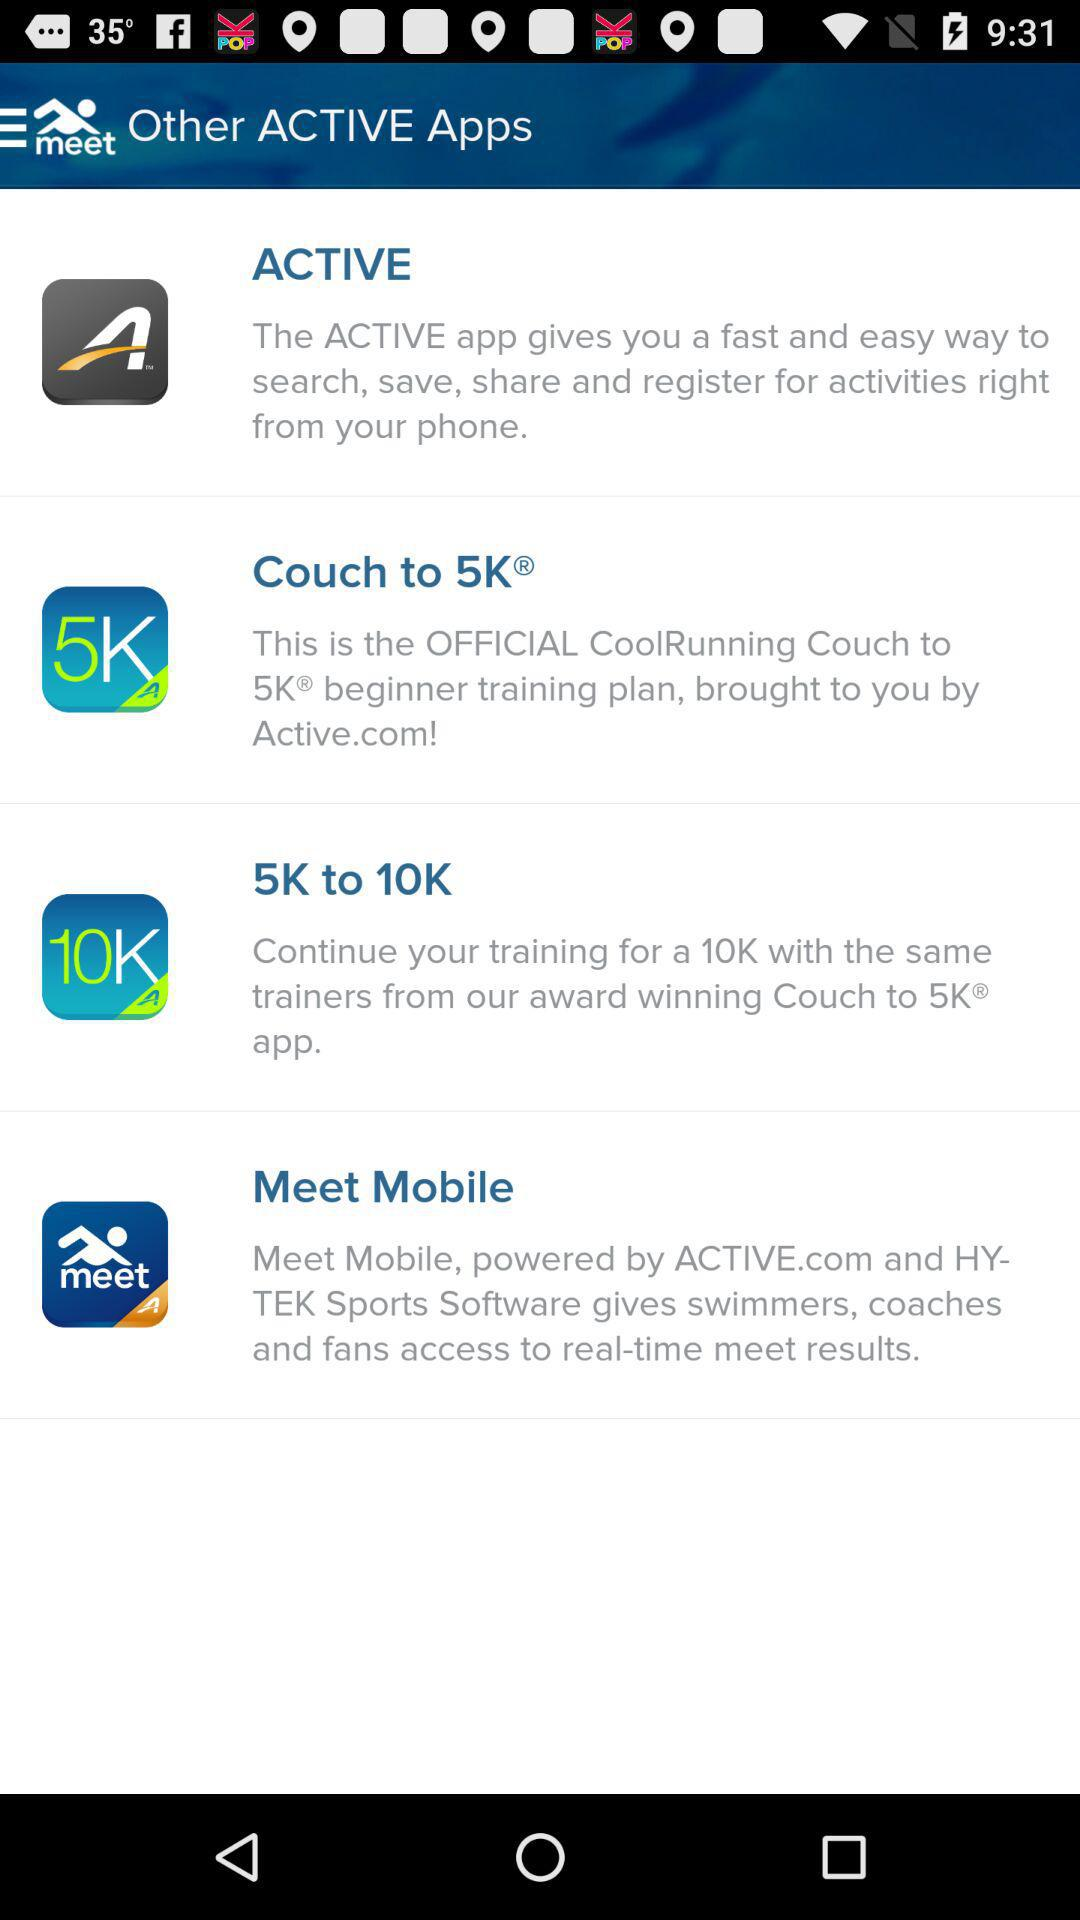What is the application name? The application names are "ACTIVE", "Couch to 5K", "5K to 10K" and "Meet Mobile". 